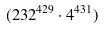Convert formula to latex. <formula><loc_0><loc_0><loc_500><loc_500>( 2 3 2 ^ { 4 2 9 } \cdot 4 ^ { 4 3 1 } )</formula> 